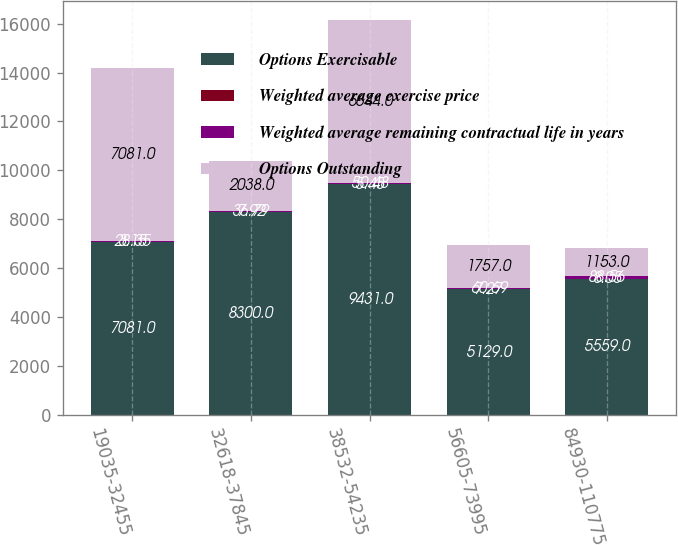Convert chart. <chart><loc_0><loc_0><loc_500><loc_500><stacked_bar_chart><ecel><fcel>19035-32455<fcel>32618-37845<fcel>38532-54235<fcel>56605-73995<fcel>84930-110775<nl><fcel>Options Exercisable<fcel>7081<fcel>8300<fcel>9431<fcel>5129<fcel>5559<nl><fcel>Weighted average exercise price<fcel>3.15<fcel>7.92<fcel>5.45<fcel>7.27<fcel>8.05<nl><fcel>Weighted average remaining contractual life in years<fcel>28.35<fcel>36.79<fcel>50.48<fcel>60.69<fcel>88.56<nl><fcel>Options Outstanding<fcel>7081<fcel>2038<fcel>6644<fcel>1757<fcel>1153<nl></chart> 